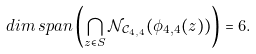Convert formula to latex. <formula><loc_0><loc_0><loc_500><loc_500>d i m \, s p a n \left ( \bigcap _ { z \in S } \mathcal { N } _ { \mathcal { C } _ { 4 , 4 } } ( \phi _ { 4 , 4 } ( z ) ) \right ) = 6 .</formula> 